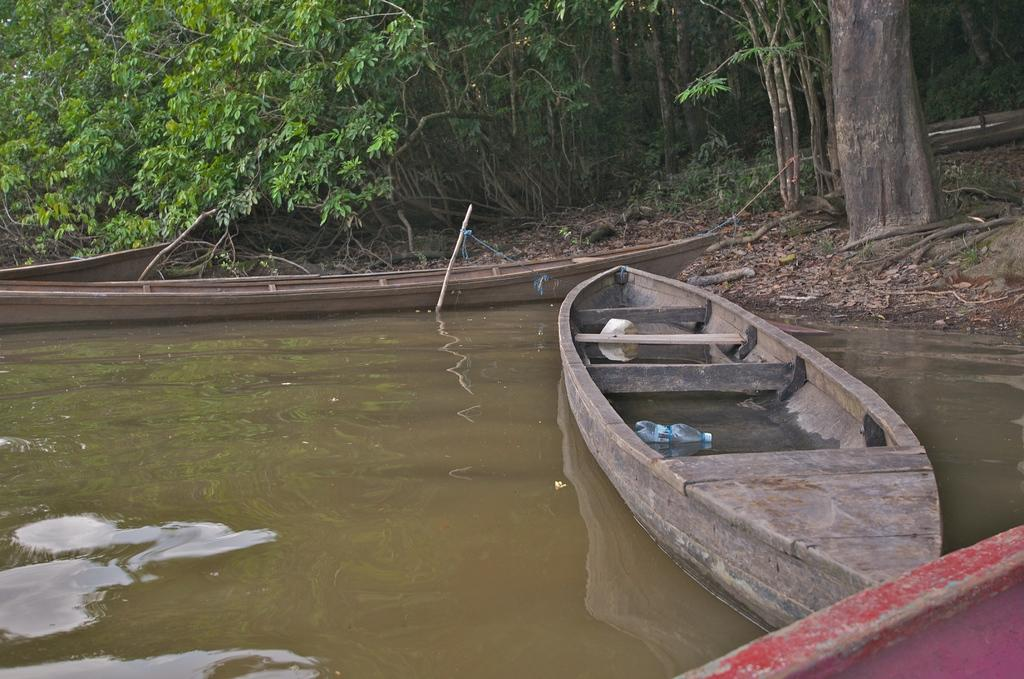What is the main subject of the image? The main subject of the image is boats. Where are the boats located? The boats are on the water. What can be found inside one of the boats? There is a bottle in one of the boats. What can be seen in the background of the image? There are many trees in the background of the image. What type of protest is happening in the room in the image? There is no room or protest present in the image; it features boats on the water with trees in the background. 